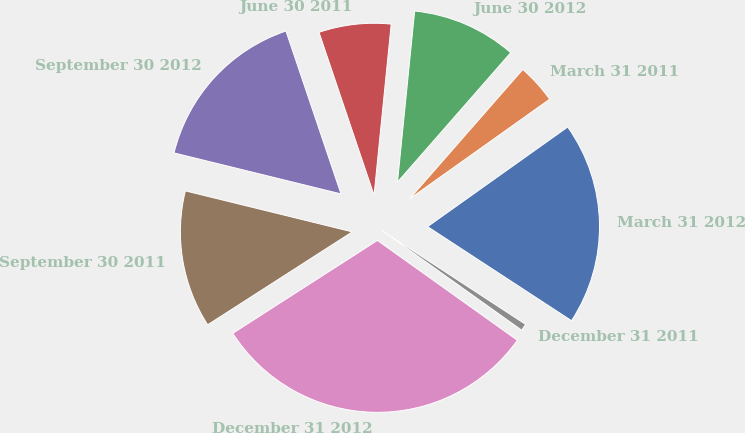<chart> <loc_0><loc_0><loc_500><loc_500><pie_chart><fcel>March 31 2012<fcel>March 31 2011<fcel>June 30 2012<fcel>June 30 2011<fcel>September 30 2012<fcel>September 30 2011<fcel>December 31 2012<fcel>December 31 2011<nl><fcel>19.05%<fcel>3.72%<fcel>9.85%<fcel>6.78%<fcel>15.98%<fcel>12.92%<fcel>31.05%<fcel>0.65%<nl></chart> 